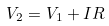<formula> <loc_0><loc_0><loc_500><loc_500>V _ { 2 } = V _ { 1 } + I R</formula> 